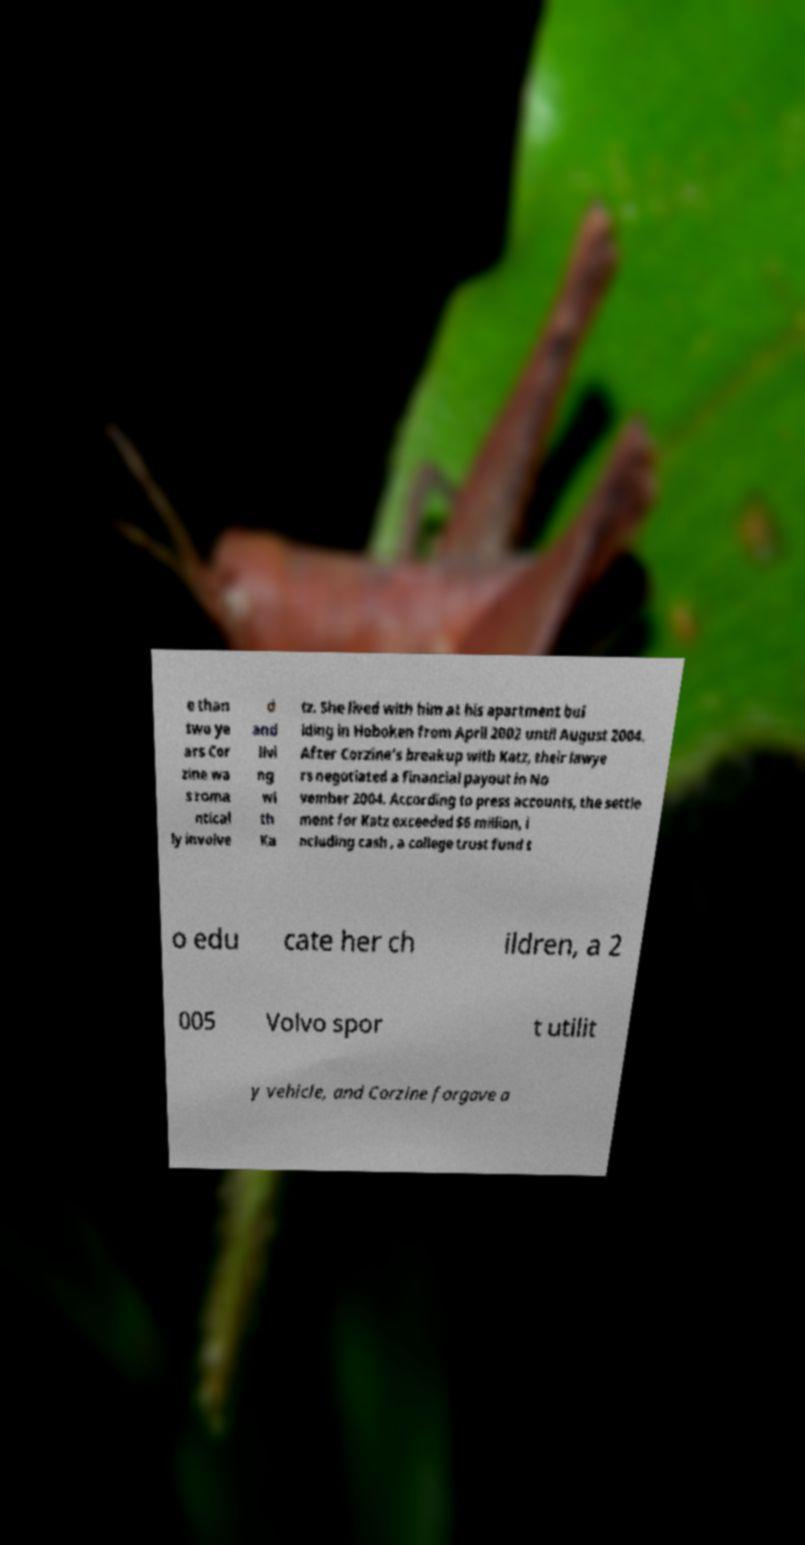Can you read and provide the text displayed in the image?This photo seems to have some interesting text. Can you extract and type it out for me? e than two ye ars Cor zine wa s roma ntical ly involve d and livi ng wi th Ka tz. She lived with him at his apartment bui lding in Hoboken from April 2002 until August 2004. After Corzine's breakup with Katz, their lawye rs negotiated a financial payout in No vember 2004. According to press accounts, the settle ment for Katz exceeded $6 million, i ncluding cash , a college trust fund t o edu cate her ch ildren, a 2 005 Volvo spor t utilit y vehicle, and Corzine forgave a 